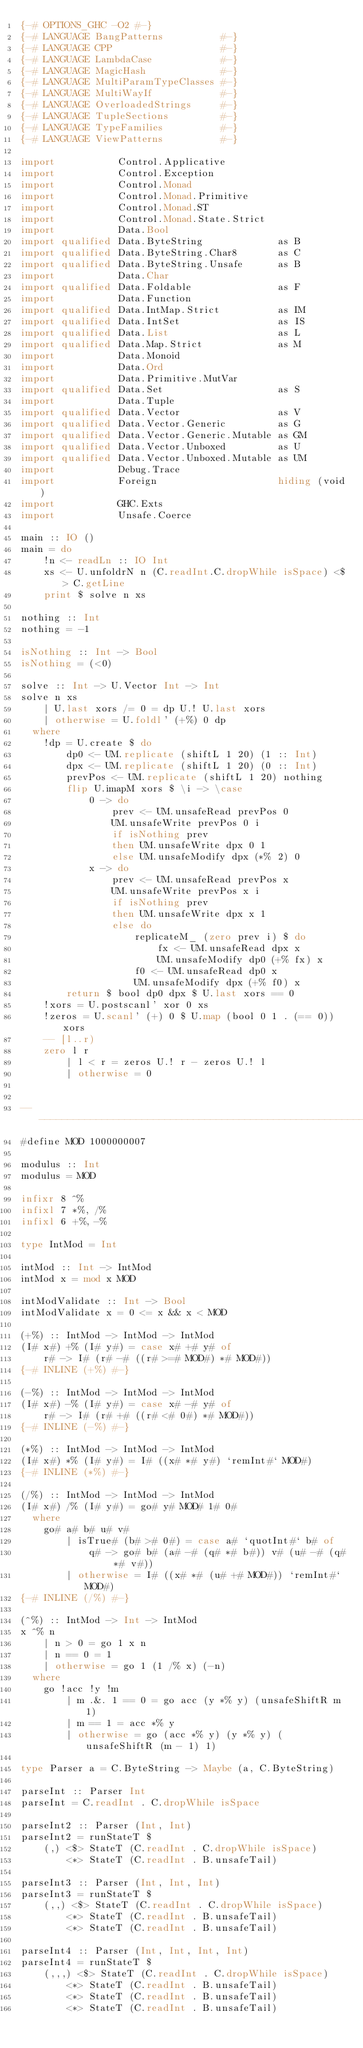<code> <loc_0><loc_0><loc_500><loc_500><_Haskell_>{-# OPTIONS_GHC -O2 #-}
{-# LANGUAGE BangPatterns          #-}
{-# LANGUAGE CPP                   #-}
{-# LANGUAGE LambdaCase            #-}
{-# LANGUAGE MagicHash             #-}
{-# LANGUAGE MultiParamTypeClasses #-}
{-# LANGUAGE MultiWayIf            #-}
{-# LANGUAGE OverloadedStrings     #-}
{-# LANGUAGE TupleSections         #-}
{-# LANGUAGE TypeFamilies          #-}
{-# LANGUAGE ViewPatterns          #-}

import           Control.Applicative
import           Control.Exception
import           Control.Monad
import           Control.Monad.Primitive
import           Control.Monad.ST
import           Control.Monad.State.Strict
import           Data.Bool
import qualified Data.ByteString             as B
import qualified Data.ByteString.Char8       as C
import qualified Data.ByteString.Unsafe      as B
import           Data.Char
import qualified Data.Foldable               as F
import           Data.Function
import qualified Data.IntMap.Strict          as IM
import qualified Data.IntSet                 as IS
import qualified Data.List                   as L
import qualified Data.Map.Strict             as M
import           Data.Monoid
import           Data.Ord
import           Data.Primitive.MutVar
import qualified Data.Set                    as S
import           Data.Tuple
import qualified Data.Vector                 as V
import qualified Data.Vector.Generic         as G
import qualified Data.Vector.Generic.Mutable as GM
import qualified Data.Vector.Unboxed         as U
import qualified Data.Vector.Unboxed.Mutable as UM
import           Debug.Trace
import           Foreign                     hiding (void)
import           GHC.Exts
import           Unsafe.Coerce

main :: IO ()
main = do
    !n <- readLn :: IO Int
    xs <- U.unfoldrN n (C.readInt.C.dropWhile isSpace) <$> C.getLine
    print $ solve n xs

nothing :: Int
nothing = -1

isNothing :: Int -> Bool
isNothing = (<0)

solve :: Int -> U.Vector Int -> Int
solve n xs
    | U.last xors /= 0 = dp U.! U.last xors
    | otherwise = U.foldl' (+%) 0 dp
  where
    !dp = U.create $ do
        dp0 <- UM.replicate (shiftL 1 20) (1 :: Int)
        dpx <- UM.replicate (shiftL 1 20) (0 :: Int)
        prevPos <- UM.replicate (shiftL 1 20) nothing
        flip U.imapM xors $ \i -> \case
            0 -> do
                prev <- UM.unsafeRead prevPos 0
                UM.unsafeWrite prevPos 0 i
                if isNothing prev
                then UM.unsafeWrite dpx 0 1
                else UM.unsafeModify dpx (*% 2) 0
            x -> do
                prev <- UM.unsafeRead prevPos x
                UM.unsafeWrite prevPos x i
                if isNothing prev
                then UM.unsafeWrite dpx x 1
                else do
                    replicateM_ (zero prev i) $ do
                        fx <- UM.unsafeRead dpx x
                        UM.unsafeModify dp0 (+% fx) x
                    f0 <- UM.unsafeRead dp0 x
                    UM.unsafeModify dpx (+% f0) x
        return $ bool dp0 dpx $ U.last xors == 0
    !xors = U.postscanl' xor 0 xs
    !zeros = U.scanl' (+) 0 $ U.map (bool 0 1 . (== 0)) xors
    -- [l..r)
    zero l r
        | l < r = zeros U.! r - zeros U.! l
        | otherwise = 0


-------------------------------------------------------------------------------
#define MOD 1000000007

modulus :: Int
modulus = MOD

infixr 8 ^%
infixl 7 *%, /%
infixl 6 +%, -%

type IntMod = Int

intMod :: Int -> IntMod
intMod x = mod x MOD

intModValidate :: Int -> Bool
intModValidate x = 0 <= x && x < MOD

(+%) :: IntMod -> IntMod -> IntMod
(I# x#) +% (I# y#) = case x# +# y# of
    r# -> I# (r# -# ((r# >=# MOD#) *# MOD#))
{-# INLINE (+%) #-}

(-%) :: IntMod -> IntMod -> IntMod
(I# x#) -% (I# y#) = case x# -# y# of
    r# -> I# (r# +# ((r# <# 0#) *# MOD#))
{-# INLINE (-%) #-}

(*%) :: IntMod -> IntMod -> IntMod
(I# x#) *% (I# y#) = I# ((x# *# y#) `remInt#` MOD#)
{-# INLINE (*%) #-}

(/%) :: IntMod -> IntMod -> IntMod
(I# x#) /% (I# y#) = go# y# MOD# 1# 0#
  where
    go# a# b# u# v#
        | isTrue# (b# ># 0#) = case a# `quotInt#` b# of
            q# -> go# b# (a# -# (q# *# b#)) v# (u# -# (q# *# v#))
        | otherwise = I# ((x# *# (u# +# MOD#)) `remInt#` MOD#)
{-# INLINE (/%) #-}

(^%) :: IntMod -> Int -> IntMod
x ^% n
    | n > 0 = go 1 x n
    | n == 0 = 1
    | otherwise = go 1 (1 /% x) (-n)
  where
    go !acc !y !m
        | m .&. 1 == 0 = go acc (y *% y) (unsafeShiftR m 1)
        | m == 1 = acc *% y
        | otherwise = go (acc *% y) (y *% y) (unsafeShiftR (m - 1) 1)

type Parser a = C.ByteString -> Maybe (a, C.ByteString)

parseInt :: Parser Int
parseInt = C.readInt . C.dropWhile isSpace

parseInt2 :: Parser (Int, Int)
parseInt2 = runStateT $
    (,) <$> StateT (C.readInt . C.dropWhile isSpace)
        <*> StateT (C.readInt . B.unsafeTail)

parseInt3 :: Parser (Int, Int, Int)
parseInt3 = runStateT $
    (,,) <$> StateT (C.readInt . C.dropWhile isSpace)
        <*> StateT (C.readInt . B.unsafeTail)
        <*> StateT (C.readInt . B.unsafeTail)

parseInt4 :: Parser (Int, Int, Int, Int)
parseInt4 = runStateT $
    (,,,) <$> StateT (C.readInt . C.dropWhile isSpace)
        <*> StateT (C.readInt . B.unsafeTail)
        <*> StateT (C.readInt . B.unsafeTail)
        <*> StateT (C.readInt . B.unsafeTail)</code> 